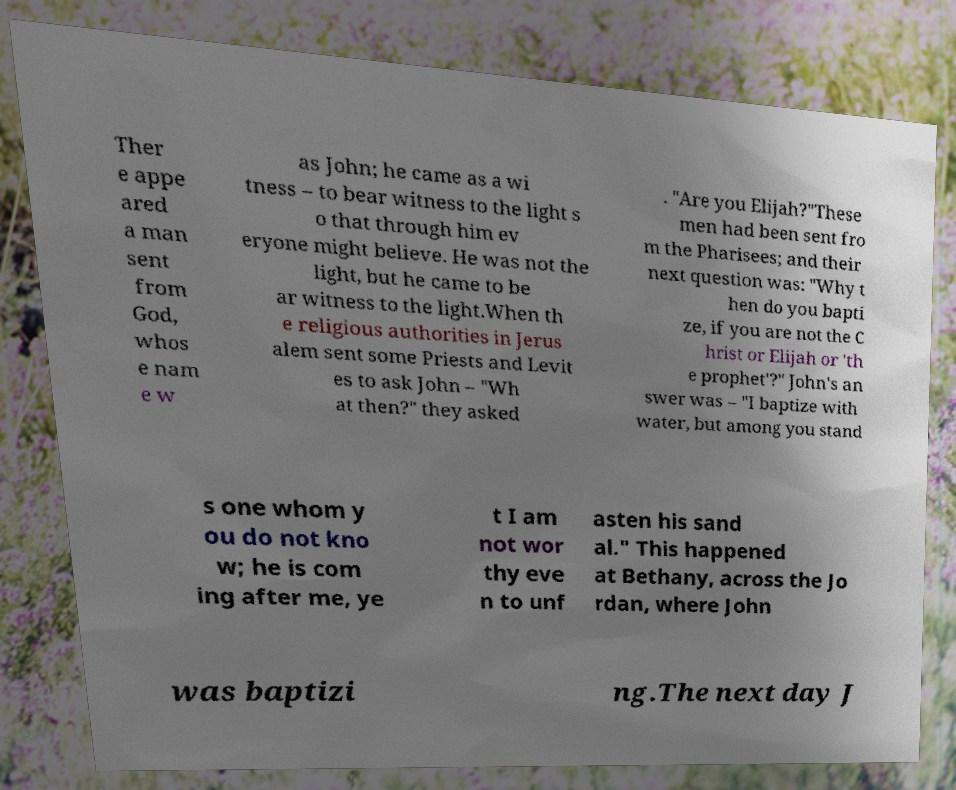Can you read and provide the text displayed in the image?This photo seems to have some interesting text. Can you extract and type it out for me? Ther e appe ared a man sent from God, whos e nam e w as John; he came as a wi tness – to bear witness to the light s o that through him ev eryone might believe. He was not the light, but he came to be ar witness to the light.When th e religious authorities in Jerus alem sent some Priests and Levit es to ask John – "Wh at then?" they asked . "Are you Elijah?"These men had been sent fro m the Pharisees; and their next question was: "Why t hen do you bapti ze, if you are not the C hrist or Elijah or 'th e prophet'?" John's an swer was – "I baptize with water, but among you stand s one whom y ou do not kno w; he is com ing after me, ye t I am not wor thy eve n to unf asten his sand al." This happened at Bethany, across the Jo rdan, where John was baptizi ng.The next day J 